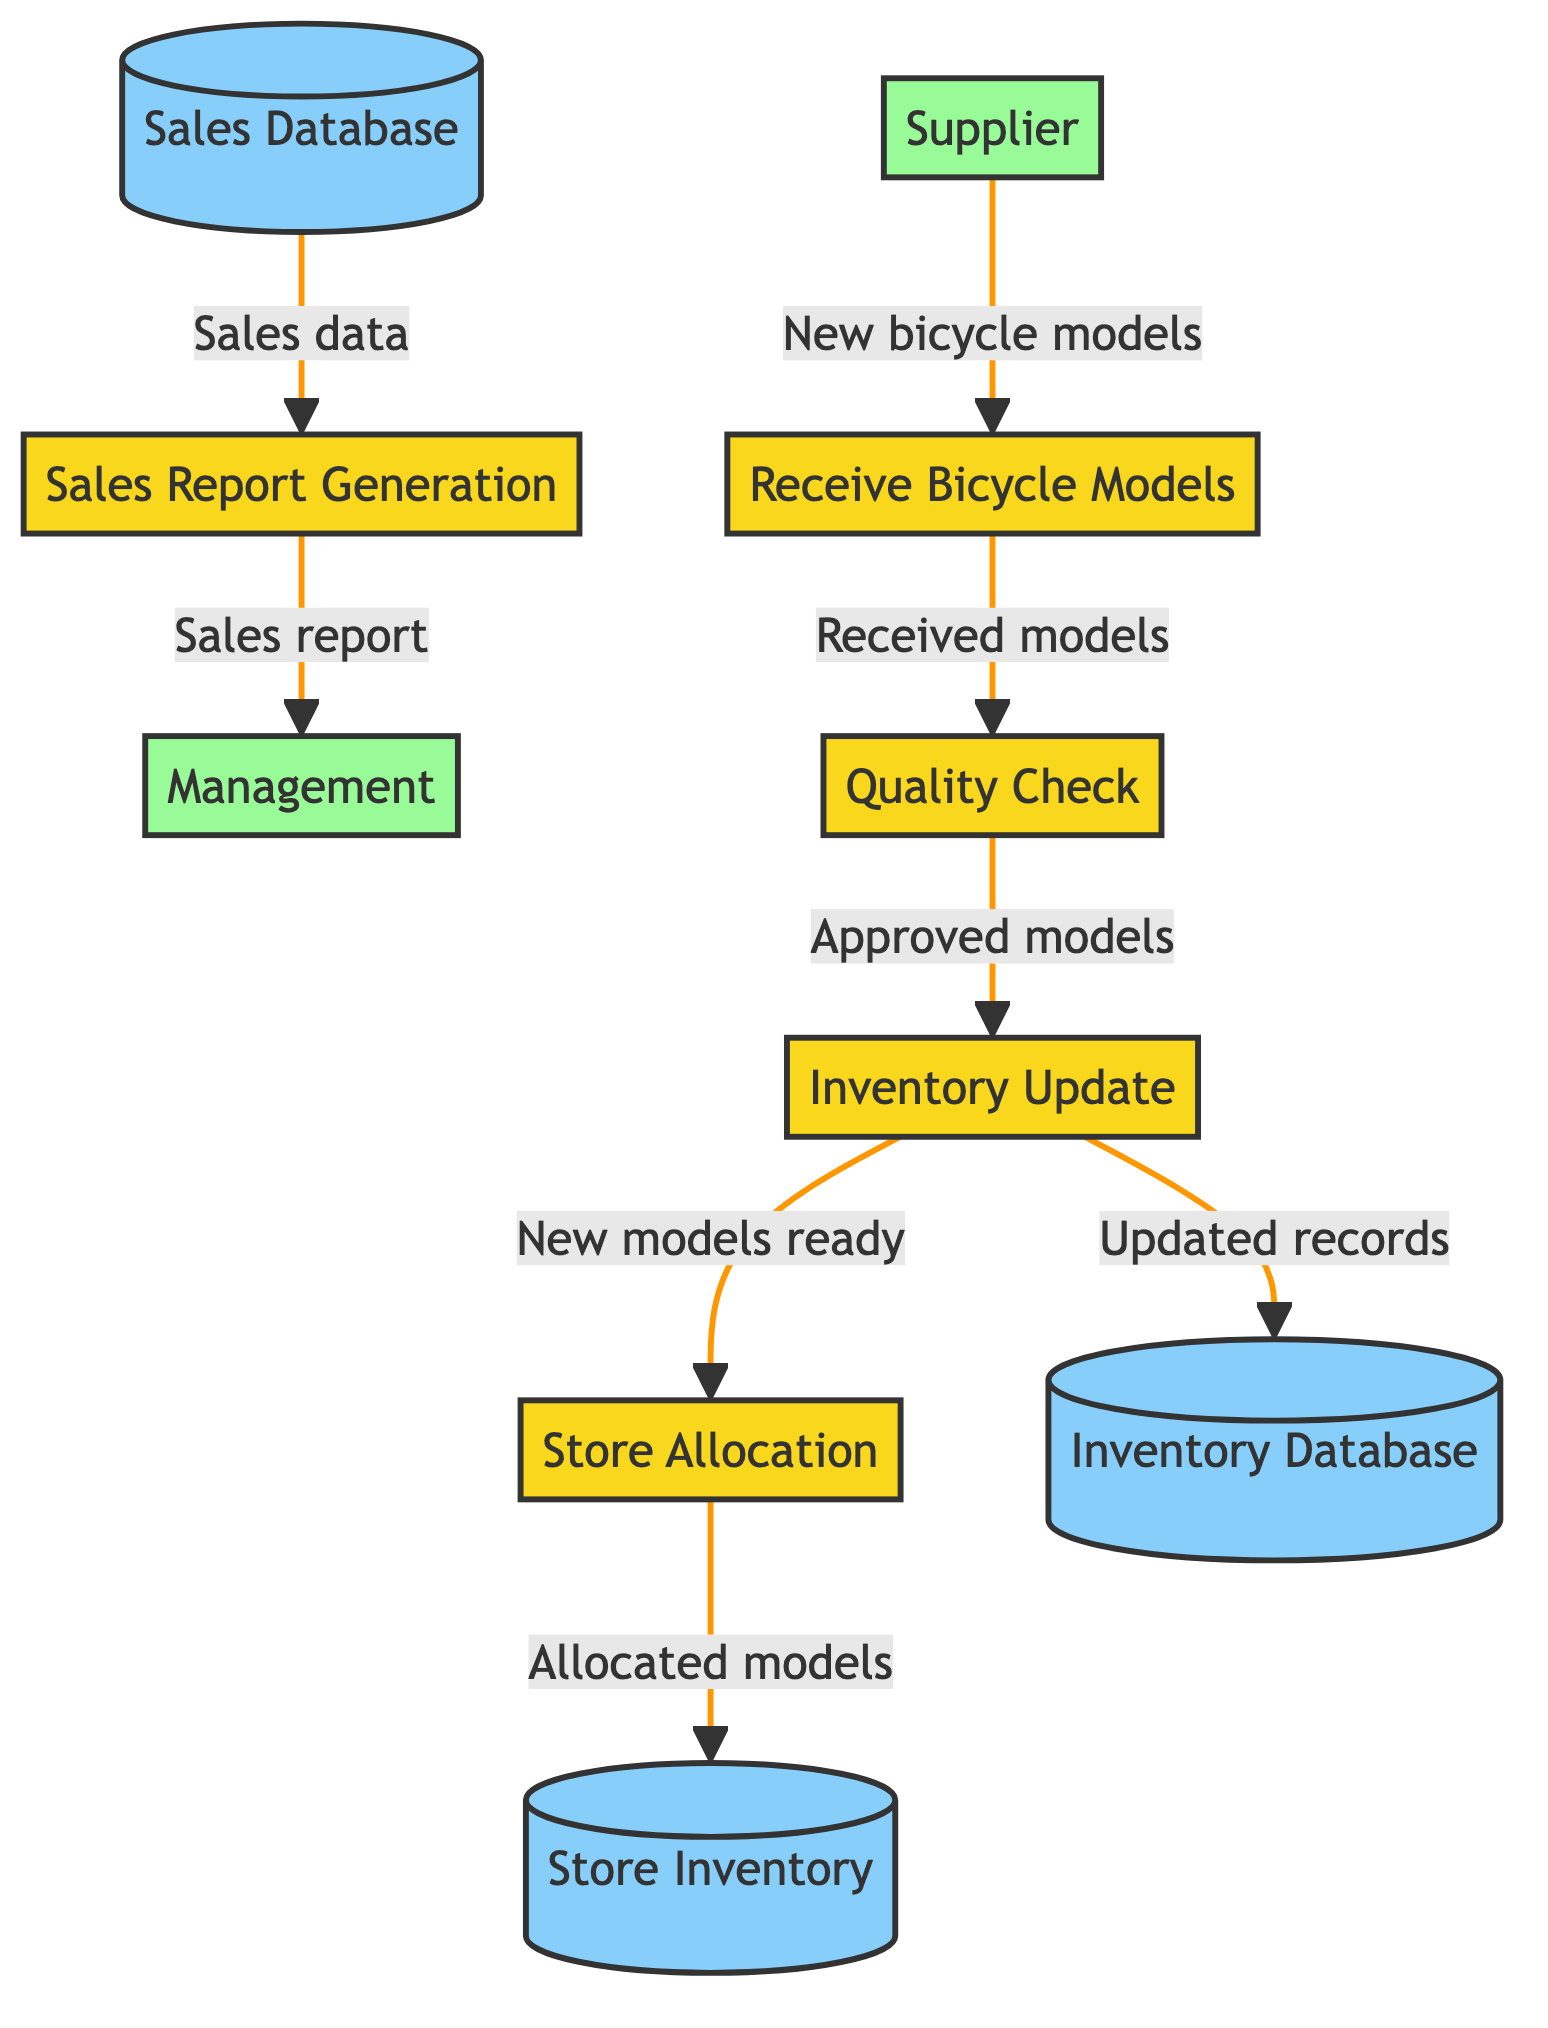What is the first process in the diagram? The first process in the diagram is indicated as "Receive Bicycle Models,” which is the initial step where new models are received from the supplier.
Answer: Receive Bicycle Models How many processes are shown in the diagram? The diagram lists five distinct processes: Receive Bicycle Models, Quality Check, Inventory Update, Store Allocation, and Sales Report Generation, making a total of five processes.
Answer: 5 What does the data flow from "P3" indicate? The data flow from "P3" (Inventory Update) indicates that updated records are sent to the Inventory Database and new models are sent for store allocation. This shows that after updating inventory, the bicycle models are allocated to stores.
Answer: Updated records and new models ready Where does "Sales Data" come from before being sent to "P5"? "Sales Data" originates from the Sales Database before being processed in "P5" for report generation. The data flow shows that sales information is required for generating sales reports.
Answer: Sales Database Which external entity requires the sales report? The external entity that requires the sales report is identified as "Management," indicating that they are the recipients of the report generated from the sales data.
Answer: Management What is the final destination of the flow labeled "Sales report"? The final destination of the flow labeled "Sales report" is toward "Management," who receives the generated sales report after the data has been processed.
Answer: Management Which data store is updated by "P3"? The data store that is updated by "P3" (Inventory Update) is the "Inventory Database," which maintains the detailed records of bicycle models in inventory.
Answer: Inventory Database What process follows "Quality Check"? The process that follows "Quality Check" (P2) is "Inventory Update" (P3), indicating that once the bicycles pass quality inspection, they are then updated in the inventory system.
Answer: Inventory Update How many distinct data stores are present in the diagram? The diagram includes three distinct data stores: Inventory Database, Store Inventory, and Sales Database, providing a structured way to manage and access inventory and sales information.
Answer: 3 What are the bicycle models sent for after "P3"? After "P3" (Inventory Update), the bicycle models are sent for "Store Allocation" (P4), indicating the next step in the process of managing new inventory.
Answer: Store Allocation 